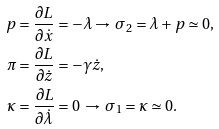Convert formula to latex. <formula><loc_0><loc_0><loc_500><loc_500>p & = \frac { \partial L } { \partial \dot { x } } = - \lambda \rightarrow \, \sigma _ { 2 } = \lambda + p \simeq 0 , \\ \pi & = \frac { \partial L } { \partial \dot { z } } = - \gamma \dot { z } , \\ \kappa & = \frac { \partial L } { \partial \dot { \lambda } } = 0 \, \rightarrow \, \sigma _ { 1 } = \kappa \simeq 0 .</formula> 